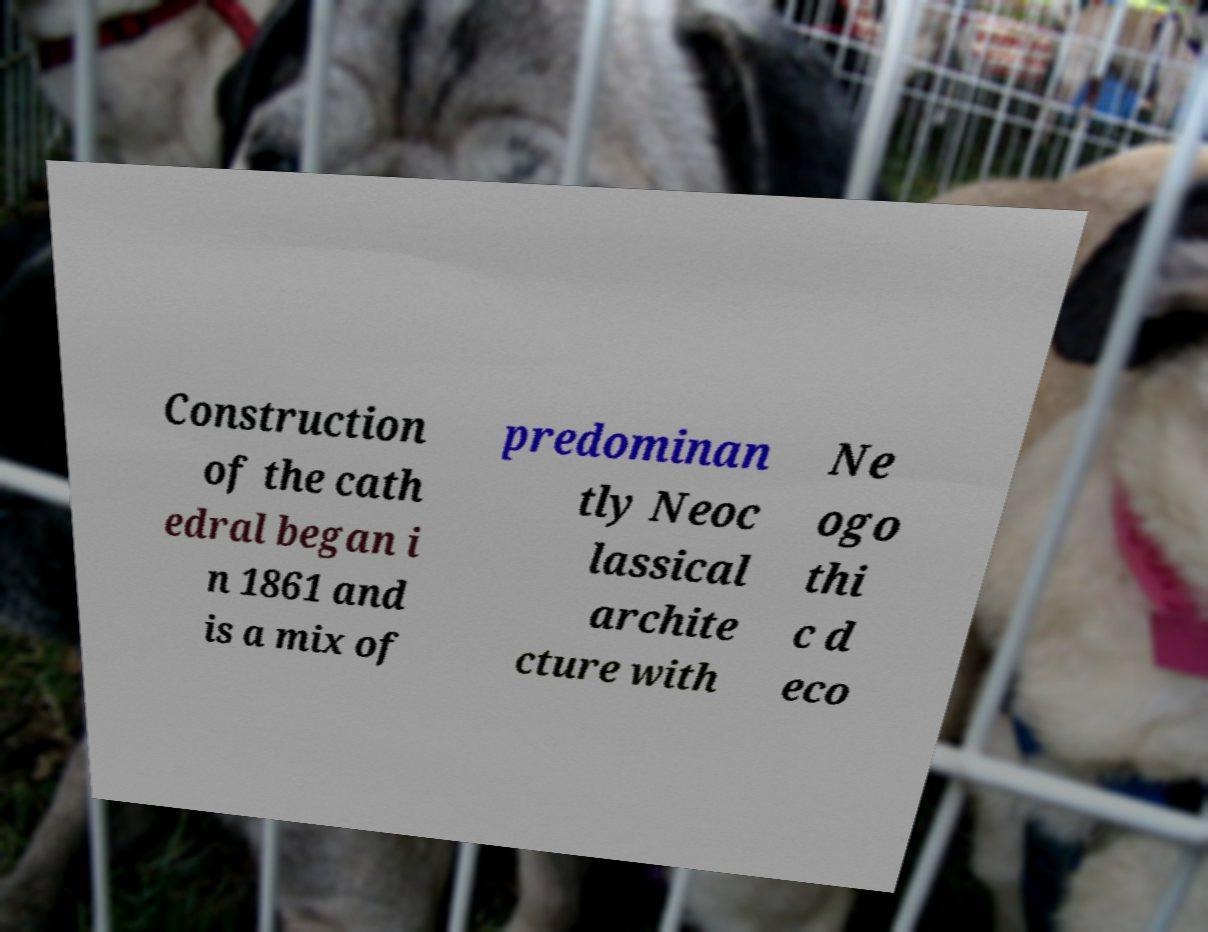Please identify and transcribe the text found in this image. Construction of the cath edral began i n 1861 and is a mix of predominan tly Neoc lassical archite cture with Ne ogo thi c d eco 